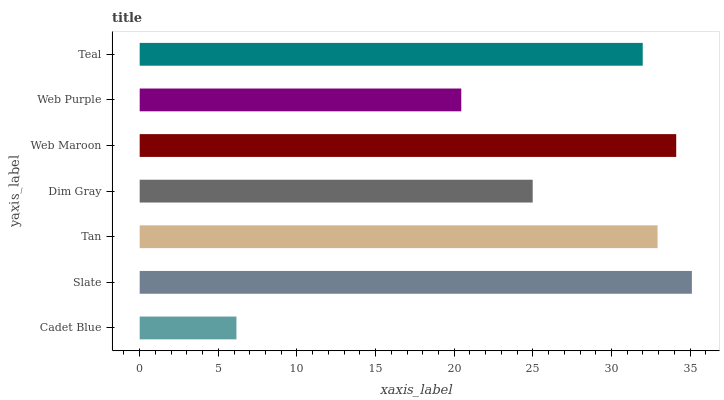Is Cadet Blue the minimum?
Answer yes or no. Yes. Is Slate the maximum?
Answer yes or no. Yes. Is Tan the minimum?
Answer yes or no. No. Is Tan the maximum?
Answer yes or no. No. Is Slate greater than Tan?
Answer yes or no. Yes. Is Tan less than Slate?
Answer yes or no. Yes. Is Tan greater than Slate?
Answer yes or no. No. Is Slate less than Tan?
Answer yes or no. No. Is Teal the high median?
Answer yes or no. Yes. Is Teal the low median?
Answer yes or no. Yes. Is Cadet Blue the high median?
Answer yes or no. No. Is Tan the low median?
Answer yes or no. No. 